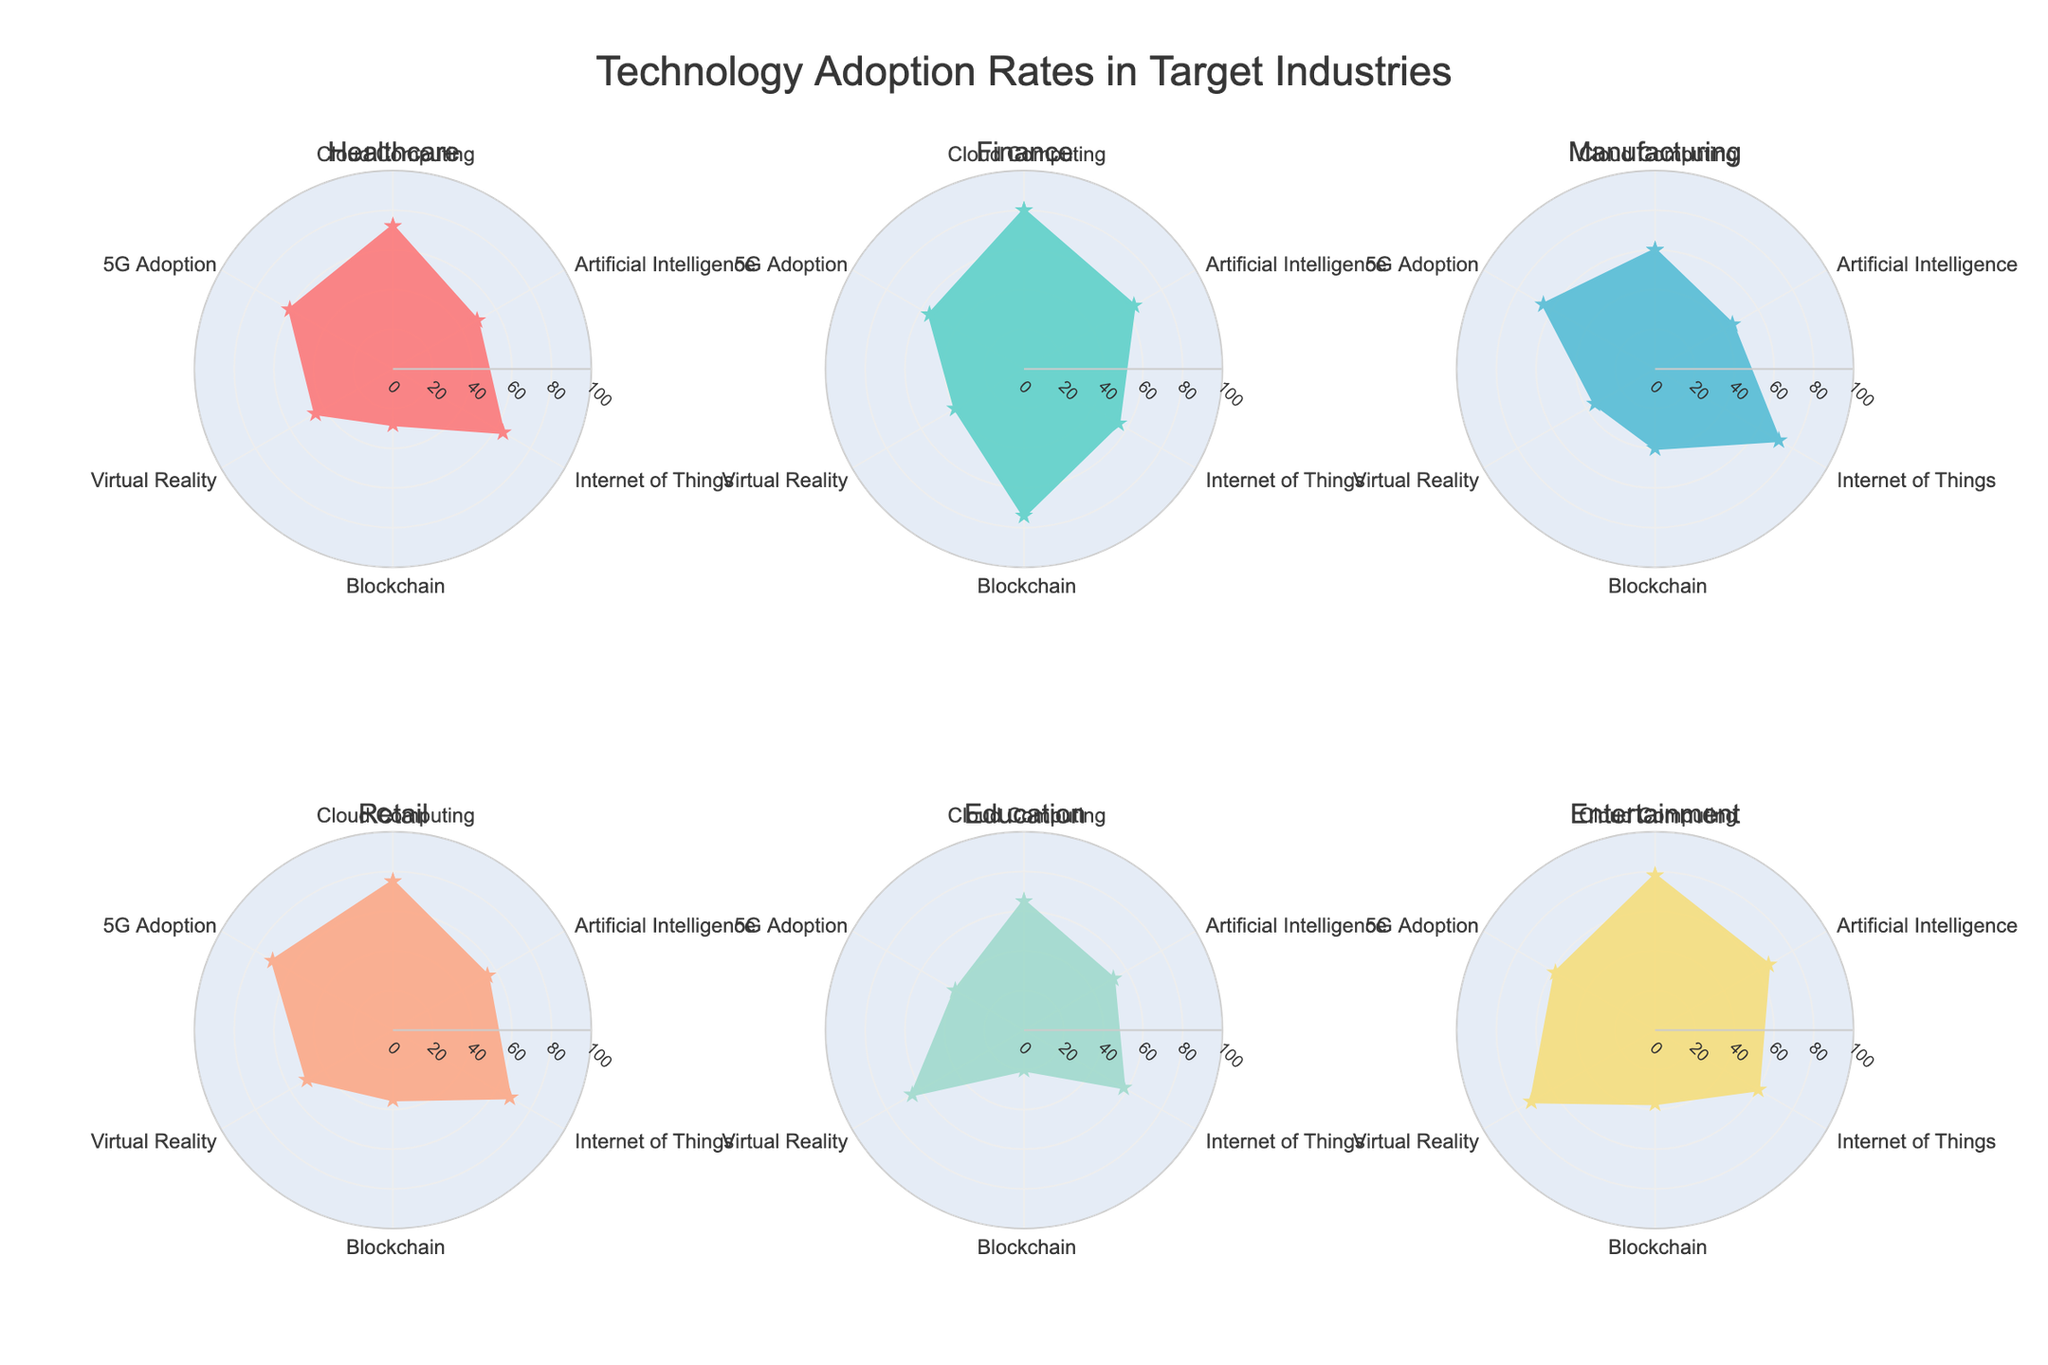How many industries are displayed in the radar charts? The radar charts display six industries as individual subplots. The title of each subplot is the name of an industry. By counting these titles, one can determine the total number of industries.
Answer: Six In which industry is Artificial Intelligence adoption the highest? By observing the figures, the adoption rate for Artificial Intelligence is highest in the Entertainment industry compared to others.
Answer: Entertainment What is the average 5G adoption rate across all industries? To find the average 5G adoption rate, sum the adoption rates for all industries and divide by the number of industries. (60 + 55 + 65 + 70 + 40 + 58) / 6 = 58
Answer: 58 Which industry has the lowest adoption rate for Blockchain? By examining each subplot for the Blockchain adoption rate, the Education industry has the lowest rate at 20.
Answer: Education Are there any industries where Cloud Computing adoption exceeds 70%? Yes, the Healthcare (72), Finance (80), Retail (75), and Entertainment (78) industries all exceed 70%.
Answer: Yes Between Healthcare and Manufacturing, which industry has a higher Internet of Things adoption rate, and by how much? The Internet of Things adoption rate for Healthcare is 64 and for Manufacturing is 72. The difference is 72 - 64 = 8, meaning Manufacturing is higher by 8%.
Answer: Manufacturing, by 8% What's the minimum adoption rate for Virtual Reality among all industries? The minimum adoption rate for Virtual Reality can be identified by looking at each figure. The lowest rate is 35 in the Retail industry.
Answer: 35 Which technology has the most consistent adoption rate across all industries? By comparing the variability of each technology across the industries, Cloud Computing shows relatively high values with modest variability indicating it is the most consistent.
Answer: Cloud Computing If the Finance industry's adoption rates for Internet of Things and Blockchain were swapped, how would this affect its overall technology adoption landscape in the radar chart? Swapping values, Internet of Things would be 74, and Blockchain would be 55. This change would make the radar chart more balanced, especially in the peaks for these technologies, as now the peaks would be closer in magnitude.
Answer: Balanced radar and closer peaks What percentage increase does Entertainment have in Virtual Reality adoption over Finance? Entertainment's Virtual Reality adoption is 72%, and Finance's is 40%. The increase is calculated as ((72 - 40)/40) * 100 = 80%.
Answer: 80% 